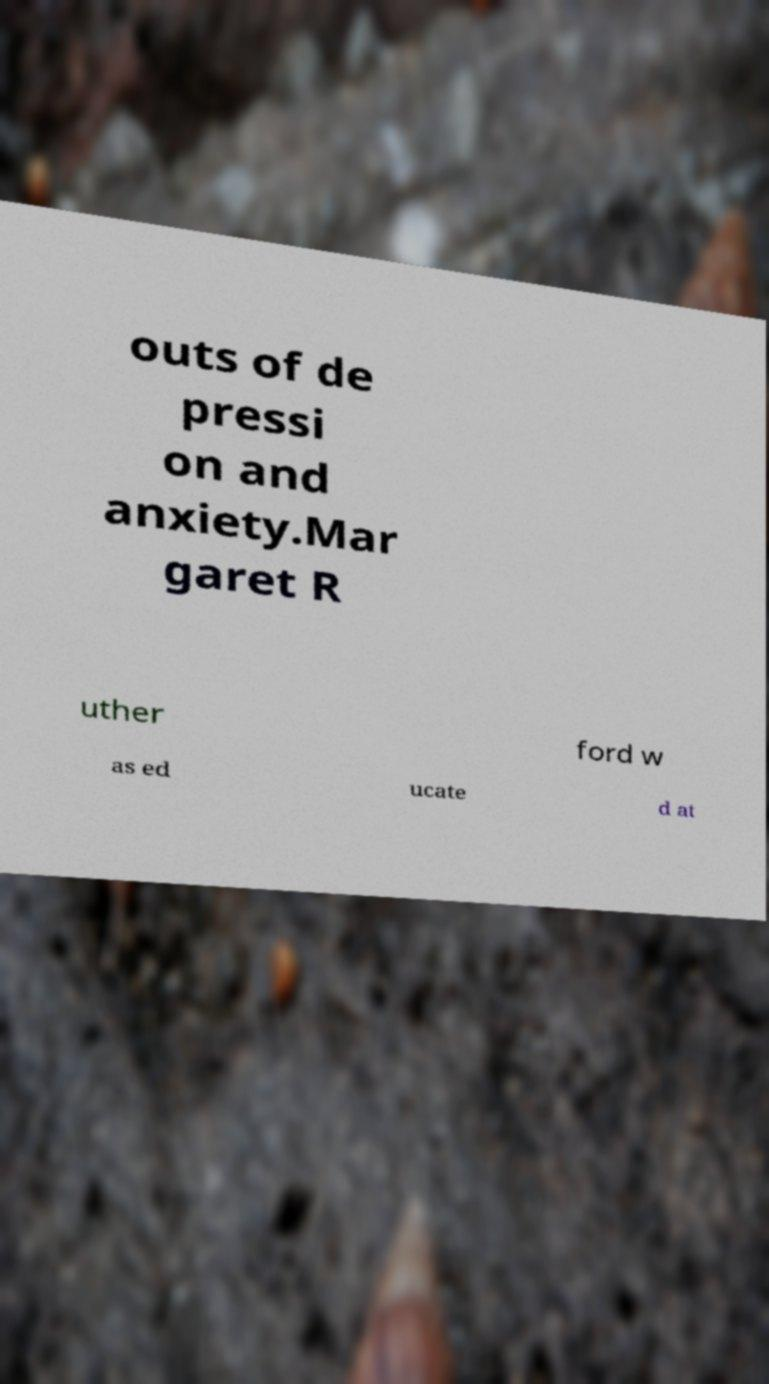Can you accurately transcribe the text from the provided image for me? outs of de pressi on and anxiety.Mar garet R uther ford w as ed ucate d at 